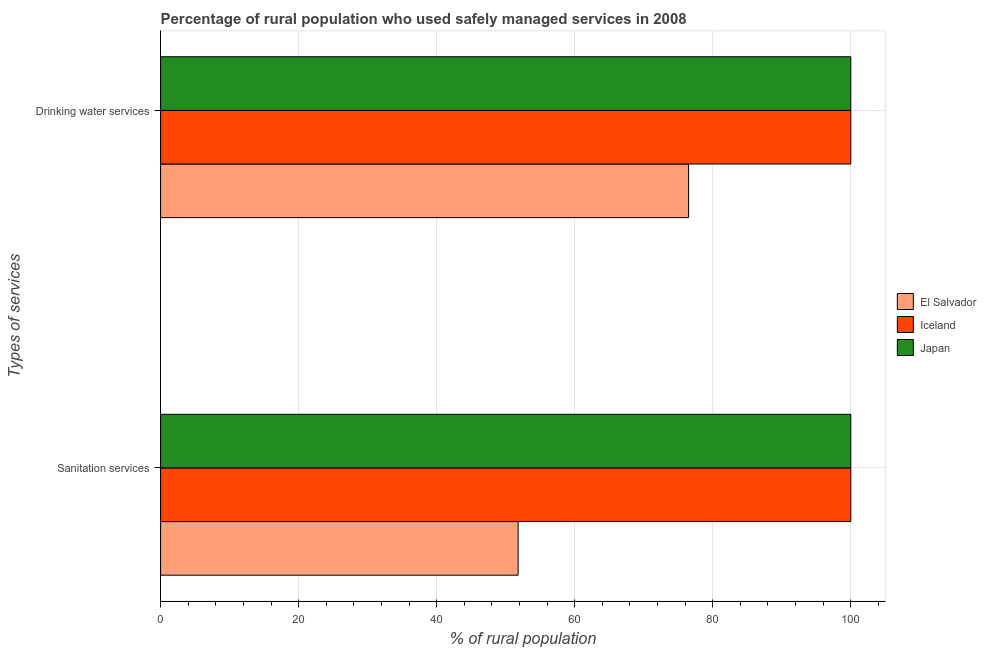How many different coloured bars are there?
Provide a succinct answer. 3. Are the number of bars on each tick of the Y-axis equal?
Give a very brief answer. Yes. How many bars are there on the 1st tick from the top?
Your answer should be compact. 3. What is the label of the 2nd group of bars from the top?
Provide a short and direct response. Sanitation services. What is the percentage of rural population who used drinking water services in El Salvador?
Ensure brevity in your answer.  76.5. Across all countries, what is the minimum percentage of rural population who used sanitation services?
Your answer should be compact. 51.8. In which country was the percentage of rural population who used sanitation services maximum?
Provide a succinct answer. Iceland. In which country was the percentage of rural population who used sanitation services minimum?
Your answer should be very brief. El Salvador. What is the total percentage of rural population who used drinking water services in the graph?
Give a very brief answer. 276.5. What is the difference between the percentage of rural population who used sanitation services in Iceland and that in El Salvador?
Provide a succinct answer. 48.2. What is the average percentage of rural population who used drinking water services per country?
Ensure brevity in your answer.  92.17. In how many countries, is the percentage of rural population who used drinking water services greater than 4 %?
Give a very brief answer. 3. What is the ratio of the percentage of rural population who used drinking water services in Iceland to that in Japan?
Your answer should be compact. 1. What does the 3rd bar from the top in Sanitation services represents?
Make the answer very short. El Salvador. What does the 1st bar from the bottom in Drinking water services represents?
Offer a terse response. El Salvador. How many countries are there in the graph?
Ensure brevity in your answer.  3. Does the graph contain grids?
Offer a terse response. Yes. How many legend labels are there?
Offer a very short reply. 3. What is the title of the graph?
Keep it short and to the point. Percentage of rural population who used safely managed services in 2008. What is the label or title of the X-axis?
Provide a short and direct response. % of rural population. What is the label or title of the Y-axis?
Provide a succinct answer. Types of services. What is the % of rural population of El Salvador in Sanitation services?
Keep it short and to the point. 51.8. What is the % of rural population in Japan in Sanitation services?
Provide a succinct answer. 100. What is the % of rural population of El Salvador in Drinking water services?
Ensure brevity in your answer.  76.5. What is the % of rural population of Japan in Drinking water services?
Offer a very short reply. 100. Across all Types of services, what is the maximum % of rural population of El Salvador?
Your answer should be compact. 76.5. Across all Types of services, what is the minimum % of rural population in El Salvador?
Provide a succinct answer. 51.8. Across all Types of services, what is the minimum % of rural population in Japan?
Provide a succinct answer. 100. What is the total % of rural population in El Salvador in the graph?
Make the answer very short. 128.3. What is the total % of rural population of Iceland in the graph?
Your answer should be very brief. 200. What is the difference between the % of rural population in El Salvador in Sanitation services and that in Drinking water services?
Provide a succinct answer. -24.7. What is the difference between the % of rural population in Japan in Sanitation services and that in Drinking water services?
Offer a terse response. 0. What is the difference between the % of rural population in El Salvador in Sanitation services and the % of rural population in Iceland in Drinking water services?
Offer a very short reply. -48.2. What is the difference between the % of rural population in El Salvador in Sanitation services and the % of rural population in Japan in Drinking water services?
Offer a very short reply. -48.2. What is the average % of rural population of El Salvador per Types of services?
Your response must be concise. 64.15. What is the average % of rural population in Japan per Types of services?
Provide a succinct answer. 100. What is the difference between the % of rural population in El Salvador and % of rural population in Iceland in Sanitation services?
Keep it short and to the point. -48.2. What is the difference between the % of rural population of El Salvador and % of rural population of Japan in Sanitation services?
Keep it short and to the point. -48.2. What is the difference between the % of rural population in Iceland and % of rural population in Japan in Sanitation services?
Your response must be concise. 0. What is the difference between the % of rural population of El Salvador and % of rural population of Iceland in Drinking water services?
Your response must be concise. -23.5. What is the difference between the % of rural population in El Salvador and % of rural population in Japan in Drinking water services?
Offer a terse response. -23.5. What is the difference between the % of rural population of Iceland and % of rural population of Japan in Drinking water services?
Offer a terse response. 0. What is the ratio of the % of rural population of El Salvador in Sanitation services to that in Drinking water services?
Ensure brevity in your answer.  0.68. What is the difference between the highest and the second highest % of rural population in El Salvador?
Your answer should be compact. 24.7. What is the difference between the highest and the lowest % of rural population in El Salvador?
Offer a terse response. 24.7. What is the difference between the highest and the lowest % of rural population in Iceland?
Give a very brief answer. 0. 